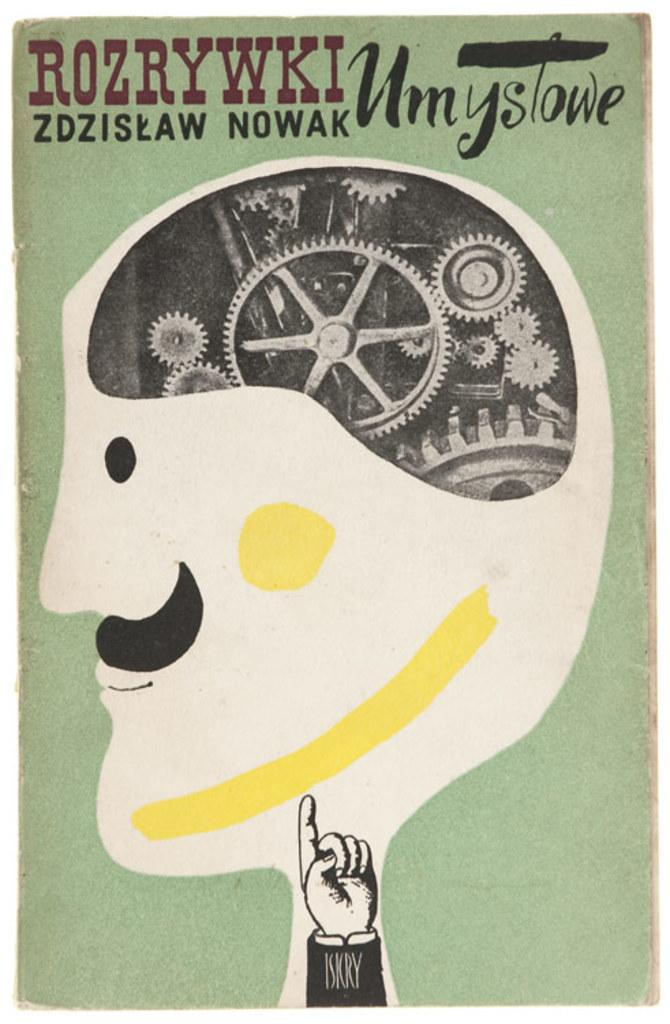<image>
Relay a brief, clear account of the picture shown. A poster shows a man with gears as brains with the words Rozrywki Umystowe at the top. 